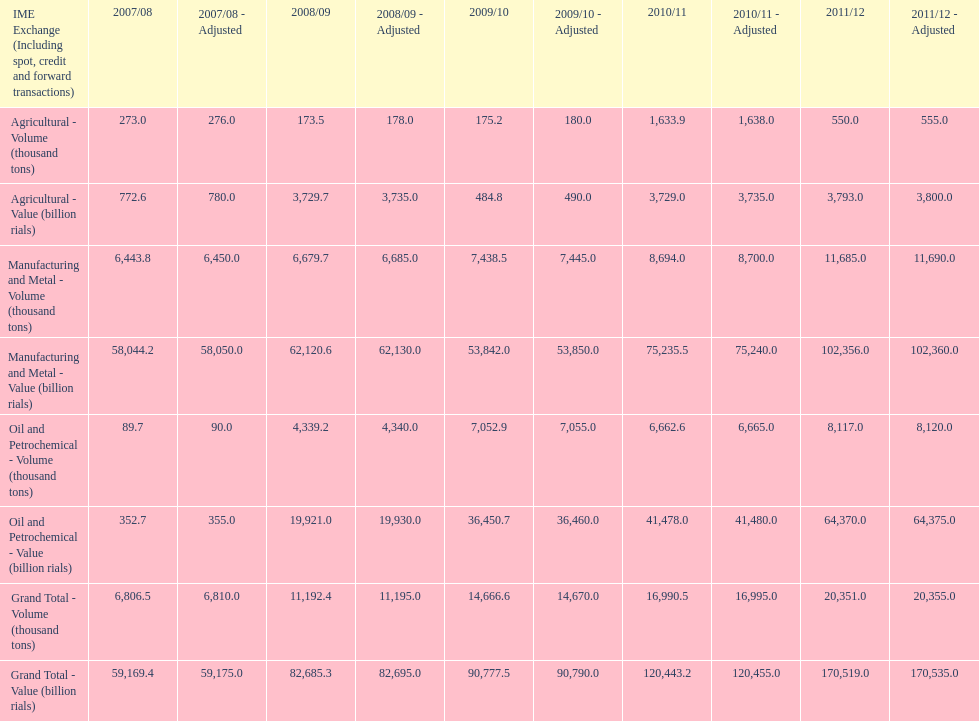Did 2010/11 or 2011/12 make more in grand total value? 2011/12. 